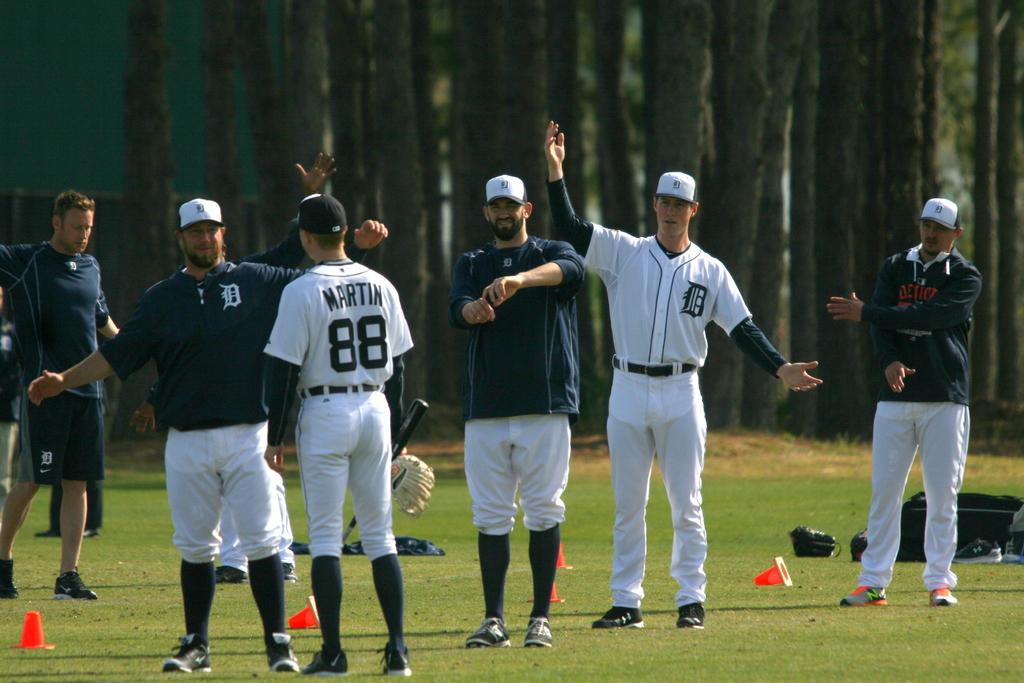<image>
Create a compact narrative representing the image presented. Baseball player Martin, number 88, is talking to people on a field. 